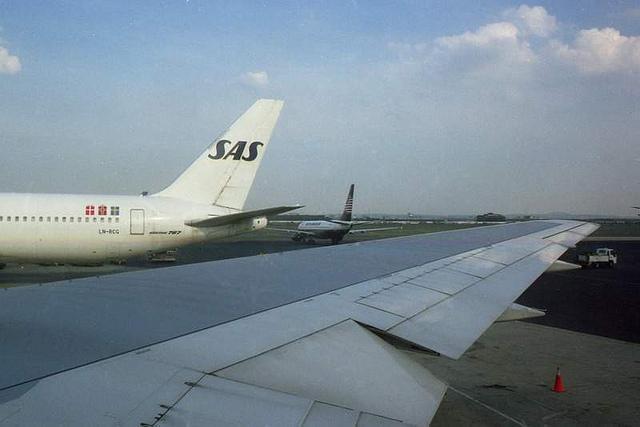How many cones are in the picture?
Give a very brief answer. 1. How many airplanes can you see?
Give a very brief answer. 2. 